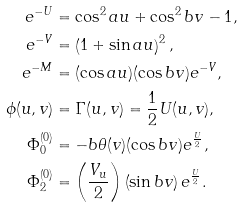<formula> <loc_0><loc_0><loc_500><loc_500>e ^ { - U } & = \cos ^ { 2 } a u + \cos ^ { 2 } b v - 1 , \\ e ^ { - V } & = \left ( 1 + \sin a u \right ) ^ { 2 } , \\ e ^ { - M } & = ( \cos a u ) ( \cos b v ) e ^ { - V } , \\ \phi ( u , v ) & = \Gamma ( u , v ) = \frac { 1 } { 2 } U ( u , v ) , \\ \Phi _ { 0 } ^ { ( 0 ) } & = - b \theta ( v ) ( \cos b v ) e ^ { \frac { U } { 2 } } , \\ \Phi _ { 2 } ^ { ( 0 ) } & = \left ( \frac { V _ { u } } { 2 } \right ) \left ( \sin b v \right ) e ^ { \frac { U } { 2 } } .</formula> 